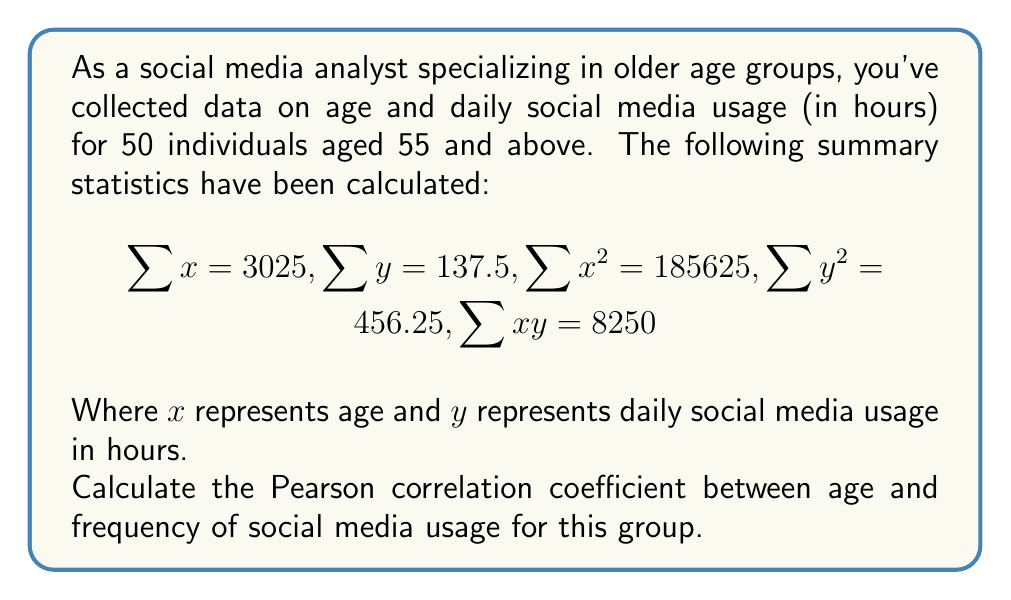Give your solution to this math problem. To calculate the Pearson correlation coefficient, we'll use the formula:

$$r = \frac{n\sum xy - \sum x \sum y}{\sqrt{[n\sum x^2 - (\sum x)^2][n\sum y^2 - (\sum y)^2]}}$$

Where $n$ is the number of data points (50 in this case).

Step 1: Calculate $n\sum xy$
$$50 \times 8250 = 412500$$

Step 2: Calculate $\sum x \sum y$
$$3025 \times 137.5 = 415937.5$$

Step 3: Calculate the numerator
$$412500 - 415937.5 = -3437.5$$

Step 4: Calculate $n\sum x^2$ and $(\sum x)^2$
$$50 \times 185625 = 9281250$$
$$(3025)^2 = 9150625$$

Step 5: Calculate $n\sum y^2$ and $(\sum y)^2$
$$50 \times 456.25 = 22812.5$$
$$(137.5)^2 = 18906.25$$

Step 6: Calculate the denominator
$$\sqrt{(9281250 - 9150625)(22812.5 - 18906.25)}$$
$$= \sqrt{130625 \times 3906.25}$$
$$= \sqrt{510320312.5}$$
$$= 22590.8$$

Step 7: Calculate the correlation coefficient
$$r = \frac{-3437.5}{22590.8} = -0.1522$$
Answer: $r \approx -0.1522$ 